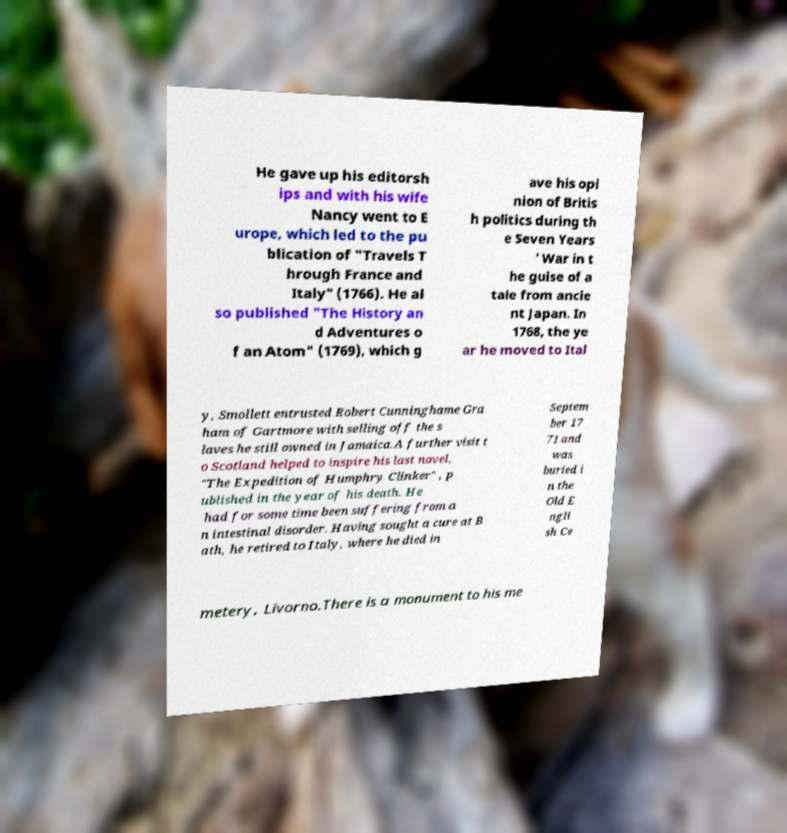There's text embedded in this image that I need extracted. Can you transcribe it verbatim? He gave up his editorsh ips and with his wife Nancy went to E urope, which led to the pu blication of "Travels T hrough France and Italy" (1766). He al so published "The History an d Adventures o f an Atom" (1769), which g ave his opi nion of Britis h politics during th e Seven Years ' War in t he guise of a tale from ancie nt Japan. In 1768, the ye ar he moved to Ital y, Smollett entrusted Robert Cunninghame Gra ham of Gartmore with selling off the s laves he still owned in Jamaica.A further visit t o Scotland helped to inspire his last novel, "The Expedition of Humphry Clinker" , p ublished in the year of his death. He had for some time been suffering from a n intestinal disorder. Having sought a cure at B ath, he retired to Italy, where he died in Septem ber 17 71 and was buried i n the Old E ngli sh Ce metery, Livorno.There is a monument to his me 